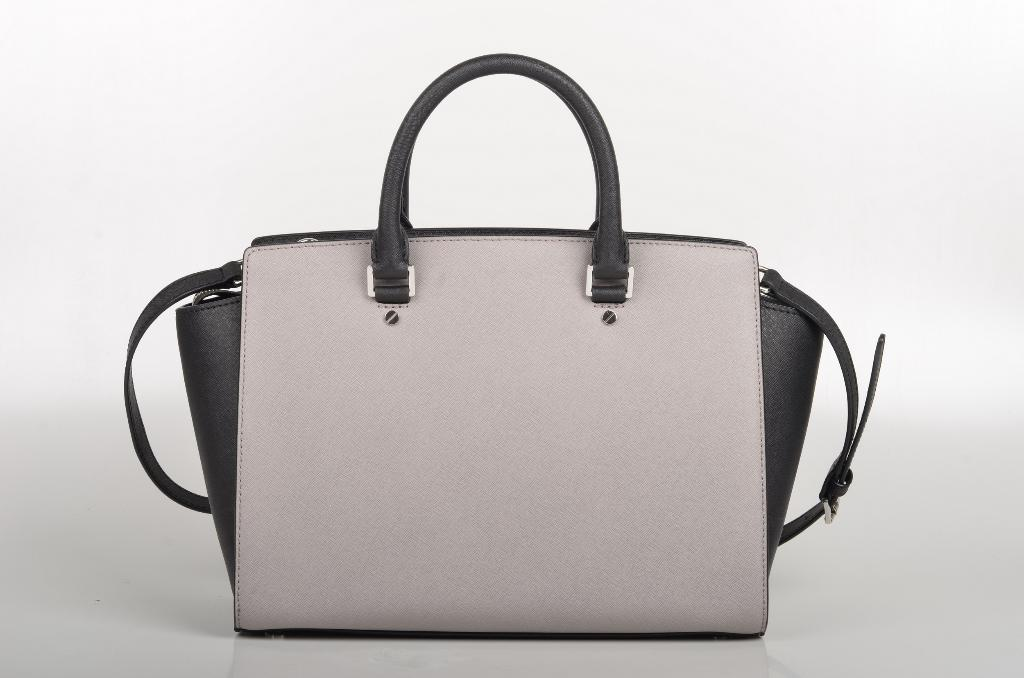What is the color of the bag in the image? The bag is grey in color. Where is the bag located in the image? The bag is on the floor. What is the color of the floor in the image? The floor is in white color. What is the color of the background in the image? The background of the image is also in white color. What emotion does the bag express in the image? The bag does not express any emotion, as it is an inanimate object. 